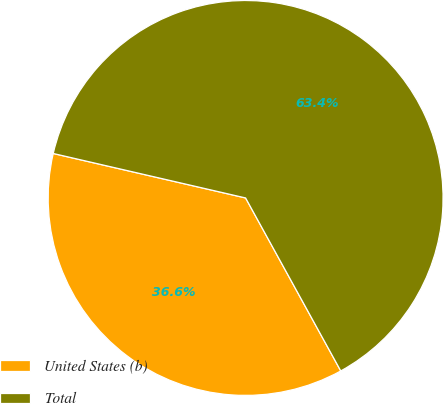<chart> <loc_0><loc_0><loc_500><loc_500><pie_chart><fcel>United States (b)<fcel>Total<nl><fcel>36.62%<fcel>63.38%<nl></chart> 